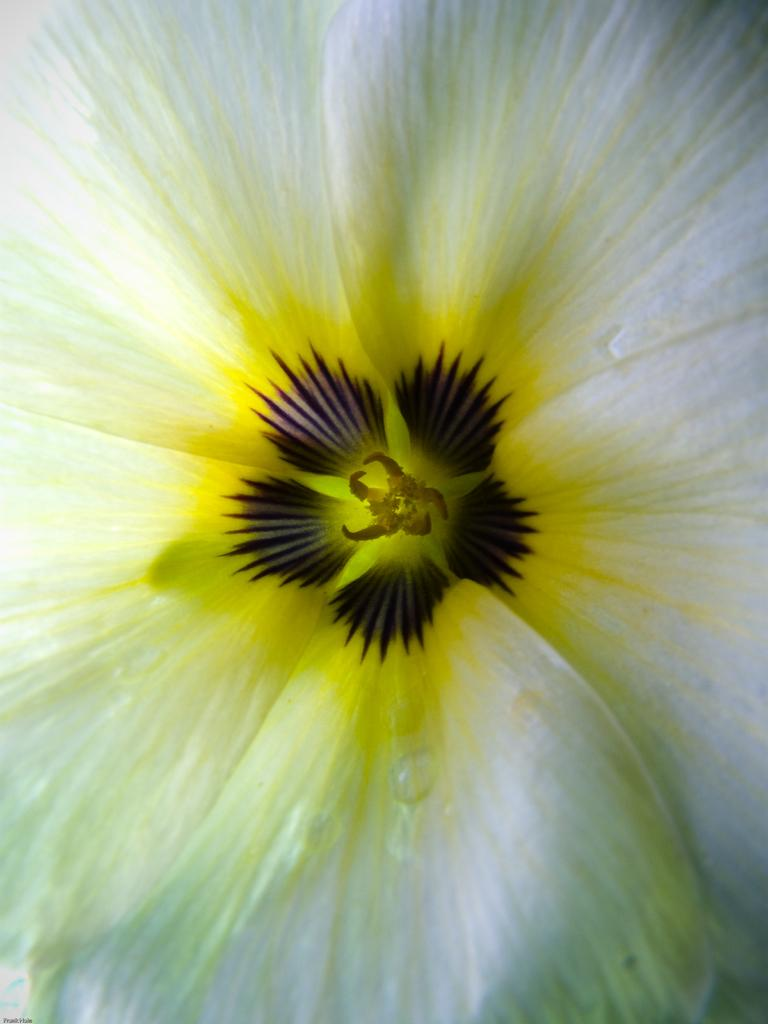What is the main subject of the image? The main subject of the image is a flower. Can you describe the colors of the flower? The flower has white, yellow, and black colors. What type of reward can be seen in the image? There is no reward present in the image; it features a flower with white, yellow, and black colors. Can you tell me where the library is in the image? There is no library present in the image; it only contains a flower. 